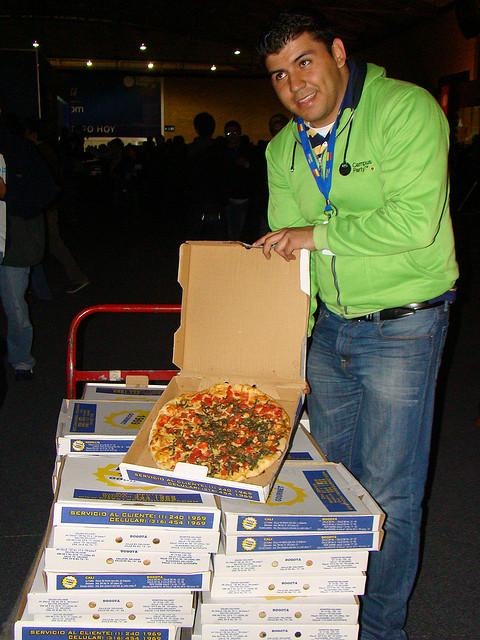What is the man doing?
Be succinct. Delivering pizza. Did this man make the pizza?
Be succinct. No. Is there plenty of donuts for people to eat?
Concise answer only. No. What type of food does the man have?
Short answer required. Pizza. 